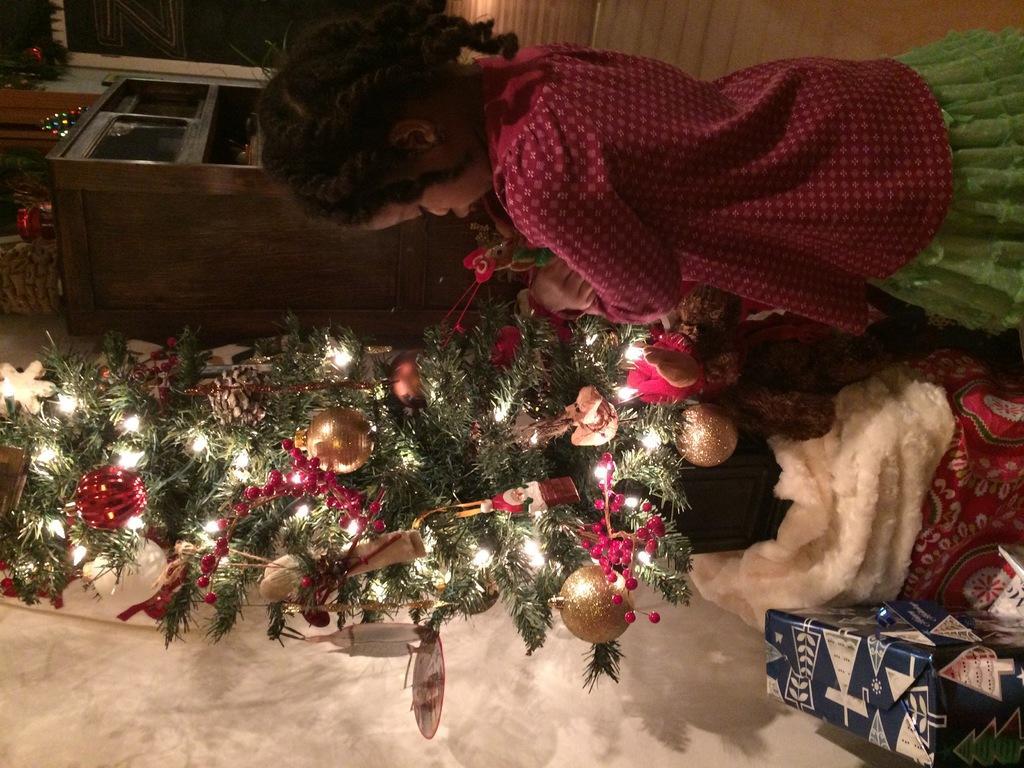Can you describe this image briefly? In this image I can see a girl wearing red and green colored dress is standing and holding few objects in her hand. I can see a tree which is green in color, few decorative items which are gold and red in color to a tree and few lights on a tree. I can see a blue colored box, few other object which are cream and red in color beside the tree. In the background I can see few trees, a brown colored cabinet and few other objects. 